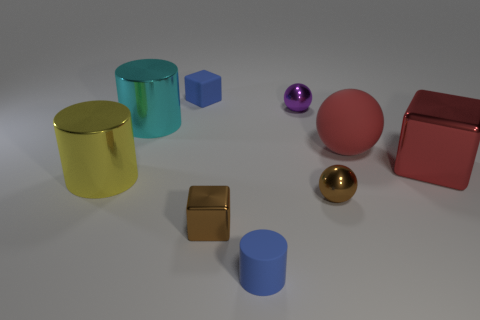There is a shiny object that is on the right side of the purple metallic object and in front of the big red block; how big is it? The shiny object in question appears small compared to the surrounding objects. It is a golden sphere, roughly the size of a standard marble or a small bouncy ball. Its compact size contrasts with the larger cylindrical objects and the hefty red block in the image. 